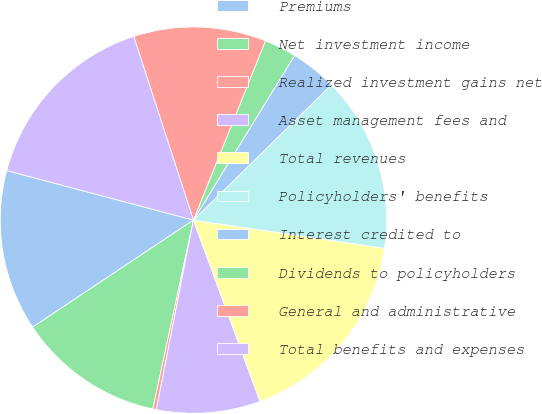<chart> <loc_0><loc_0><loc_500><loc_500><pie_chart><fcel>Premiums<fcel>Net investment income<fcel>Realized investment gains net<fcel>Asset management fees and<fcel>Total revenues<fcel>Policyholders' benefits<fcel>Interest credited to<fcel>Dividends to policyholders<fcel>General and administrative<fcel>Total benefits and expenses<nl><fcel>13.48%<fcel>12.28%<fcel>0.29%<fcel>8.68%<fcel>17.07%<fcel>14.67%<fcel>3.89%<fcel>2.69%<fcel>11.08%<fcel>15.87%<nl></chart> 